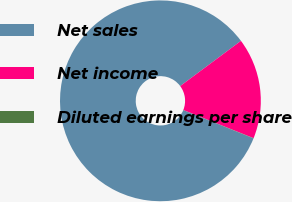Convert chart to OTSL. <chart><loc_0><loc_0><loc_500><loc_500><pie_chart><fcel>Net sales<fcel>Net income<fcel>Diluted earnings per share<nl><fcel>83.71%<fcel>16.25%<fcel>0.04%<nl></chart> 